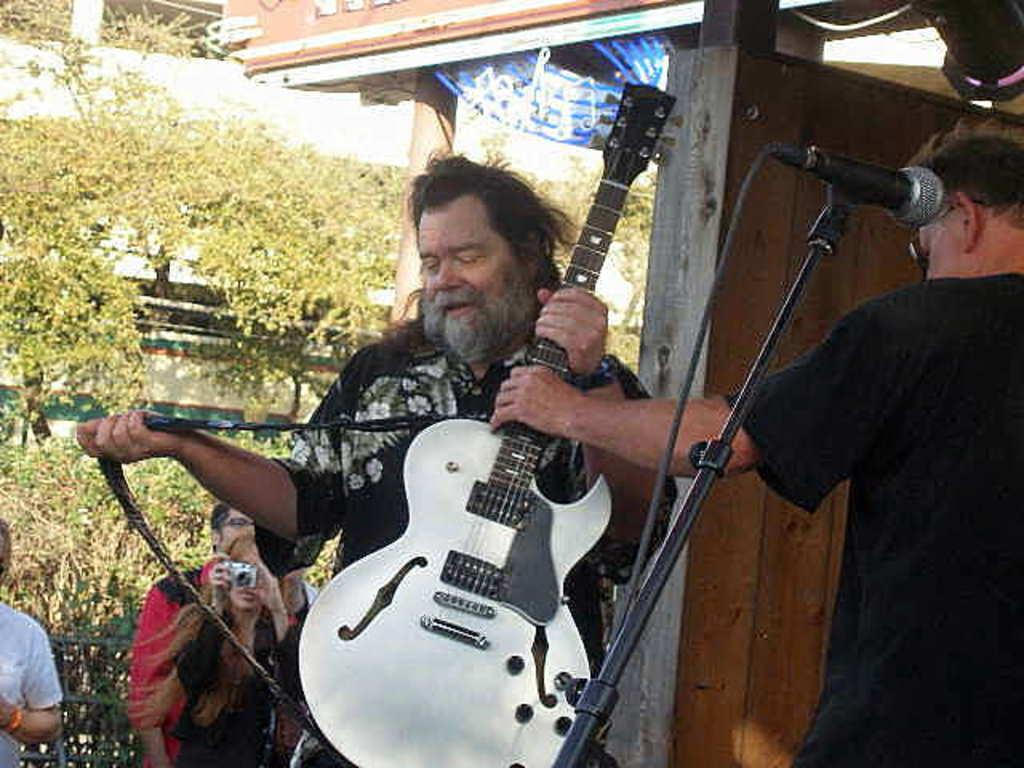How many people are in the image? There are people in the image, but the exact number is not specified. What are the people holding in the image? One person is holding a guitar, and another person is holding a camera. What other object can be seen in the image? There is a microphone (mic) in the image. What type of natural scenery is visible in the image? There are trees visible in the image. What color is the crayon being used to draw on the person's underwear in the image? There is no crayon or underwear present in the image. How many roses are visible on the person's shirt in the image? There is no mention of roses or a shirt in the image. 